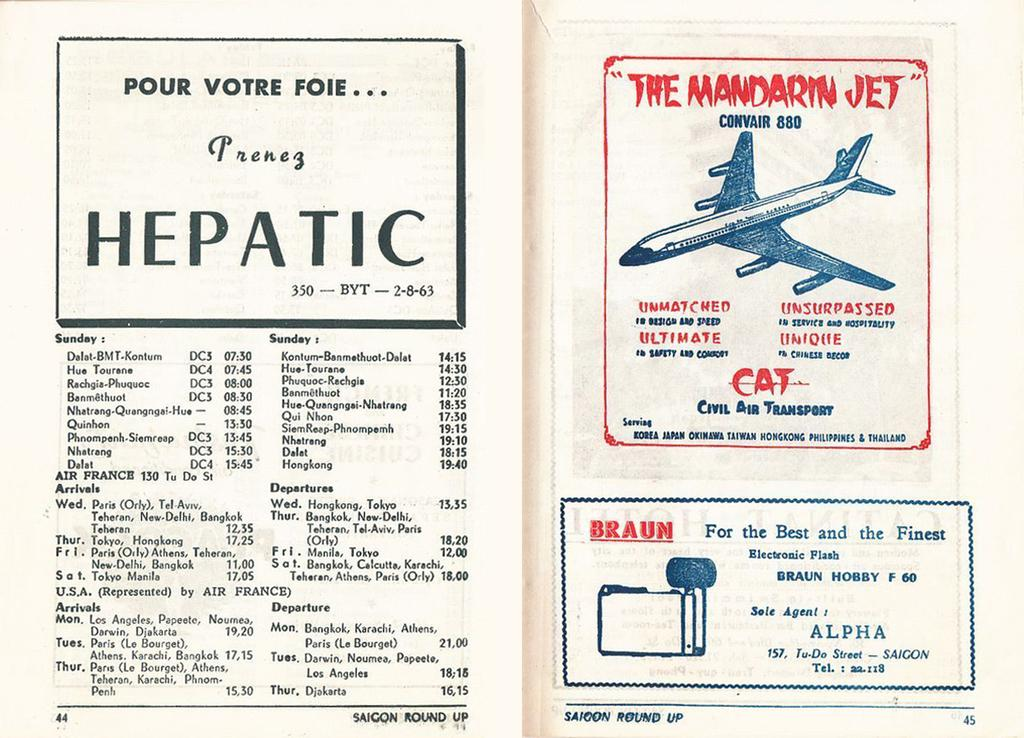What is the main subject of the image? The main subject of the image is a poster of a textbook. Are there any specific features on the poster? Yes, there are page numbers at the bottom of the poster. What type of content is present on the poster? The poster contains text, numbers, boxes, and symbols. How much does the machine cost in the image? There is no machine present in the image, so it is not possible to determine its cost. 